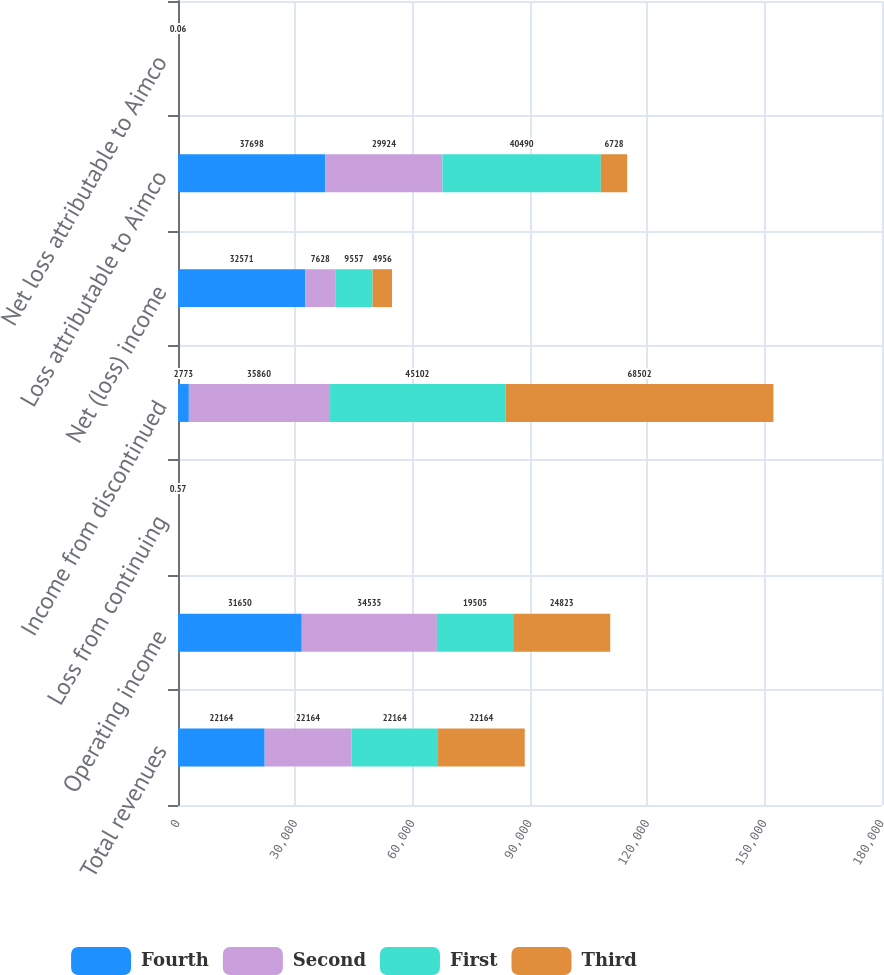Convert chart to OTSL. <chart><loc_0><loc_0><loc_500><loc_500><stacked_bar_chart><ecel><fcel>Total revenues<fcel>Operating income<fcel>Loss from continuing<fcel>Income from discontinued<fcel>Net (loss) income<fcel>Loss attributable to Aimco<fcel>Net loss attributable to Aimco<nl><fcel>Fourth<fcel>22164<fcel>31650<fcel>0.33<fcel>2773<fcel>32571<fcel>37698<fcel>0.34<nl><fcel>Second<fcel>22164<fcel>34535<fcel>0.39<fcel>35860<fcel>7628<fcel>29924<fcel>0.26<nl><fcel>First<fcel>22164<fcel>19505<fcel>0.46<fcel>45102<fcel>9557<fcel>40490<fcel>0.34<nl><fcel>Third<fcel>22164<fcel>24823<fcel>0.57<fcel>68502<fcel>4956<fcel>6728<fcel>0.06<nl></chart> 